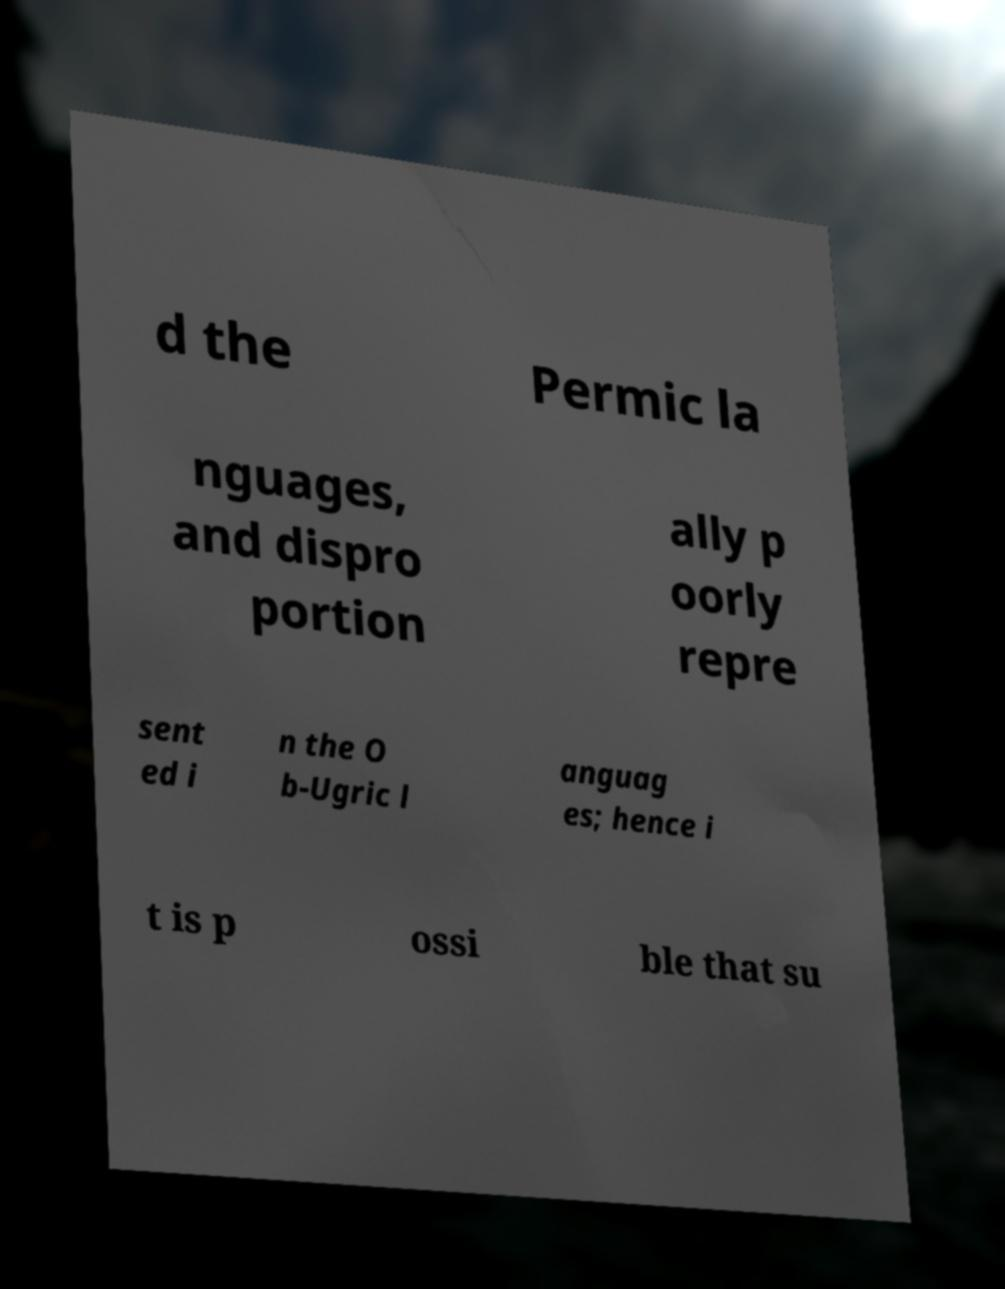Can you accurately transcribe the text from the provided image for me? d the Permic la nguages, and dispro portion ally p oorly repre sent ed i n the O b-Ugric l anguag es; hence i t is p ossi ble that su 